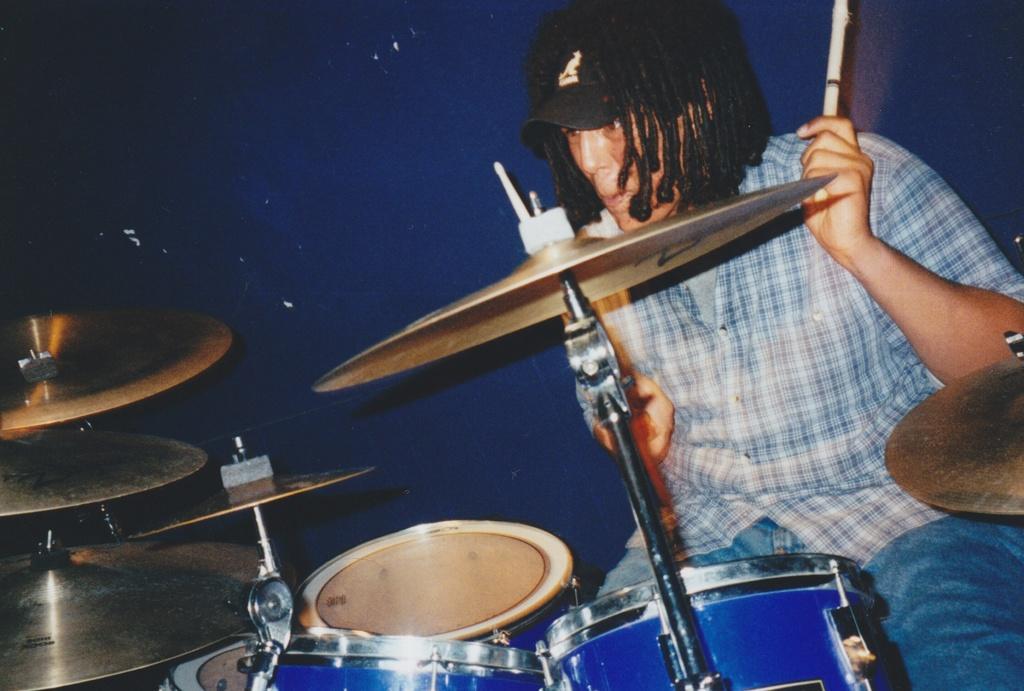Please provide a concise description of this image. In this picture we can see a person playing drums, here we can see cymbals and drums here, this person wore a cap, in the background there is a wall. 